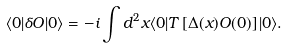Convert formula to latex. <formula><loc_0><loc_0><loc_500><loc_500>\langle 0 | \delta O | 0 \rangle = - i \int d ^ { 2 } x \langle 0 | T \left [ \Delta ( x ) O ( 0 ) \right ] | 0 \rangle .</formula> 